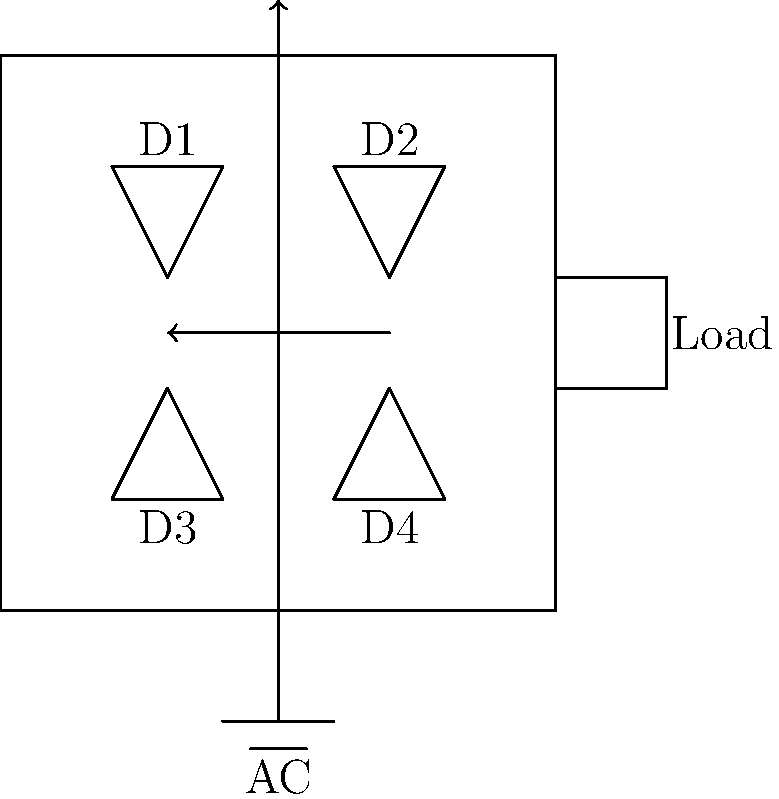In the bridge rectifier circuit shown, during the positive half-cycle of the AC input, which diodes conduct and what is the direction of current flow through the load? How does this relate to the rectification process in drug delivery systems? To understand the current flow in a bridge rectifier during the positive half-cycle of AC input, let's break it down step-by-step:

1. During the positive half-cycle, the top of the AC source is positive with respect to the bottom.

2. In this condition, diodes D1 and D4 become forward-biased and conduct current.

3. The current path is as follows:
   - From the top of the AC source
   - Through diode D1
   - Through the load (from left to right)
   - Through diode D4
   - Back to the bottom of the AC source

4. Diodes D2 and D3 are reverse-biased during this half-cycle and do not conduct.

5. This process converts the AC input into pulsating DC across the load, always flowing in the same direction (left to right in this case).

6. In the context of drug delivery systems, this rectification process is analogous to controlling the direction of drug release:
   - The AC input can be seen as the varying physiological conditions in the body.
   - The rectifier ensures a unidirectional flow, similar to how controlled release systems ensure drug delivery in a specific direction or at a controlled rate.
   - The pulsating DC output is like the pulsatile drug release patterns often used in pharmaceutical applications to mimic natural hormone release or to maintain therapeutic drug levels.

7. Understanding this process is crucial for developing electronic drug delivery systems or for analyzing the behavior of charged drug molecules under varying electromagnetic conditions in the body.
Answer: D1 and D4 conduct; current flows from left to right through the load, mimicking unidirectional controlled drug release in delivery systems. 